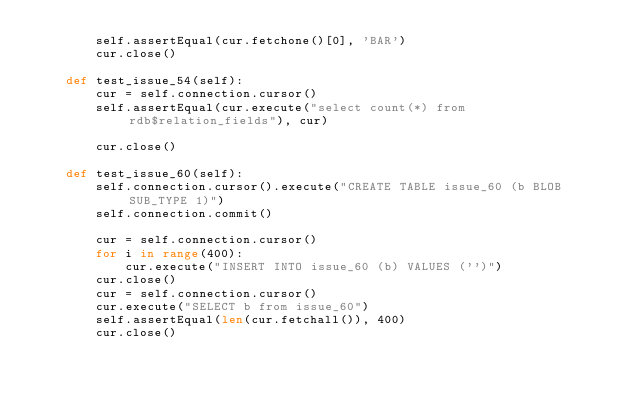<code> <loc_0><loc_0><loc_500><loc_500><_Python_>        self.assertEqual(cur.fetchone()[0], 'BAR')
        cur.close()

    def test_issue_54(self):
        cur = self.connection.cursor()
        self.assertEqual(cur.execute("select count(*) from rdb$relation_fields"), cur)

        cur.close()

    def test_issue_60(self):
        self.connection.cursor().execute("CREATE TABLE issue_60 (b BLOB SUB_TYPE 1)")
        self.connection.commit()

        cur = self.connection.cursor()
        for i in range(400):
            cur.execute("INSERT INTO issue_60 (b) VALUES ('')")
        cur.close()
        cur = self.connection.cursor()
        cur.execute("SELECT b from issue_60")
        self.assertEqual(len(cur.fetchall()), 400)
        cur.close()

</code> 